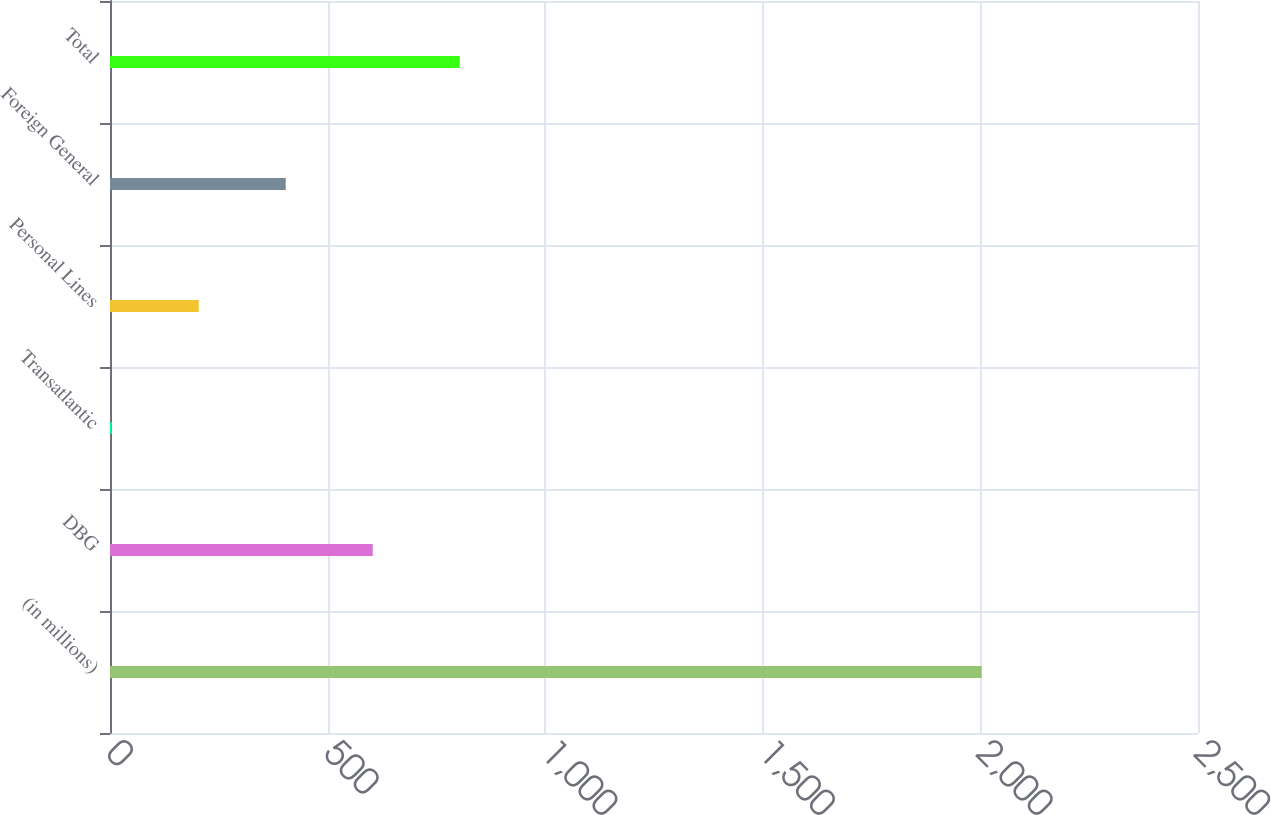Convert chart. <chart><loc_0><loc_0><loc_500><loc_500><bar_chart><fcel>(in millions)<fcel>DBG<fcel>Transatlantic<fcel>Personal Lines<fcel>Foreign General<fcel>Total<nl><fcel>2003<fcel>603.7<fcel>4<fcel>203.9<fcel>403.8<fcel>803.6<nl></chart> 